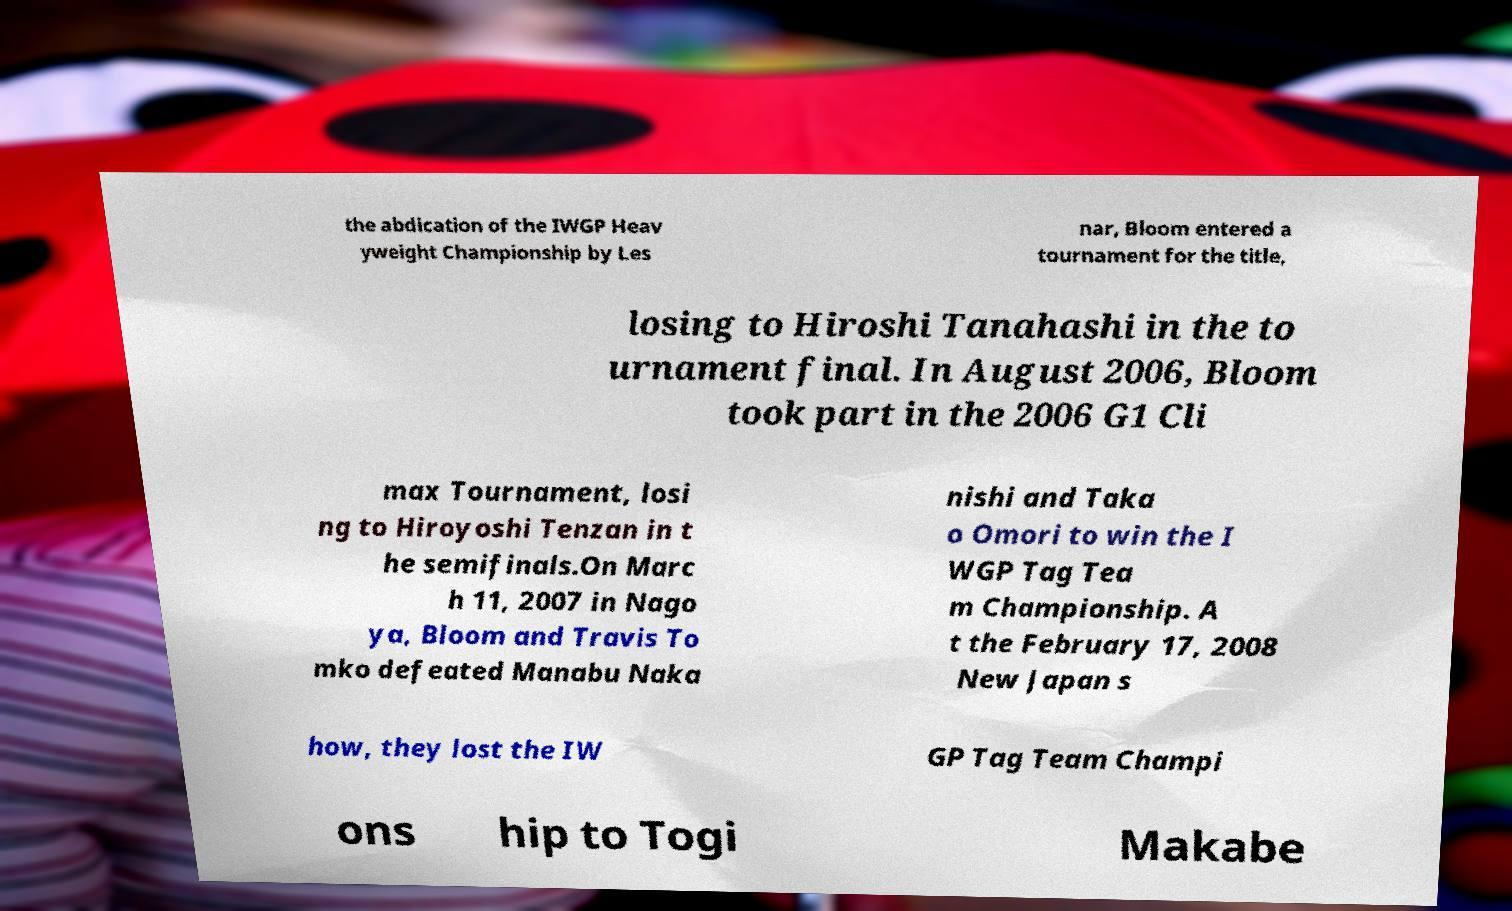Can you read and provide the text displayed in the image?This photo seems to have some interesting text. Can you extract and type it out for me? the abdication of the IWGP Heav yweight Championship by Les nar, Bloom entered a tournament for the title, losing to Hiroshi Tanahashi in the to urnament final. In August 2006, Bloom took part in the 2006 G1 Cli max Tournament, losi ng to Hiroyoshi Tenzan in t he semifinals.On Marc h 11, 2007 in Nago ya, Bloom and Travis To mko defeated Manabu Naka nishi and Taka o Omori to win the I WGP Tag Tea m Championship. A t the February 17, 2008 New Japan s how, they lost the IW GP Tag Team Champi ons hip to Togi Makabe 